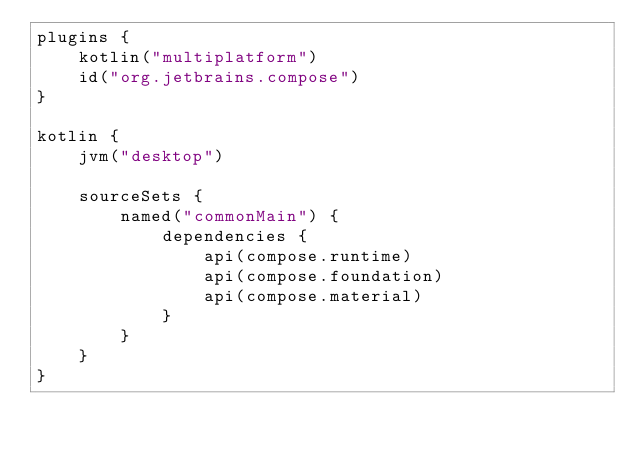Convert code to text. <code><loc_0><loc_0><loc_500><loc_500><_Kotlin_>plugins {
    kotlin("multiplatform")
    id("org.jetbrains.compose")
}

kotlin {
    jvm("desktop")

    sourceSets {
        named("commonMain") {
            dependencies {
                api(compose.runtime)
                api(compose.foundation)
                api(compose.material)
            }
        }
    }
}
</code> 